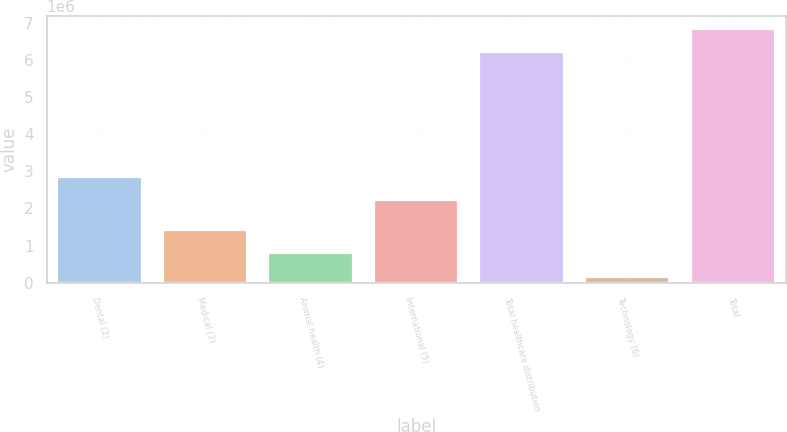<chart> <loc_0><loc_0><loc_500><loc_500><bar_chart><fcel>Dental (2)<fcel>Medical (3)<fcel>Animal health (4)<fcel>International (5)<fcel>Total healthcare distribution<fcel>Technology (6)<fcel>Total<nl><fcel>2.8428e+06<fcel>1.40671e+06<fcel>785001<fcel>2.22109e+06<fcel>6.21712e+06<fcel>163289<fcel>6.83884e+06<nl></chart> 